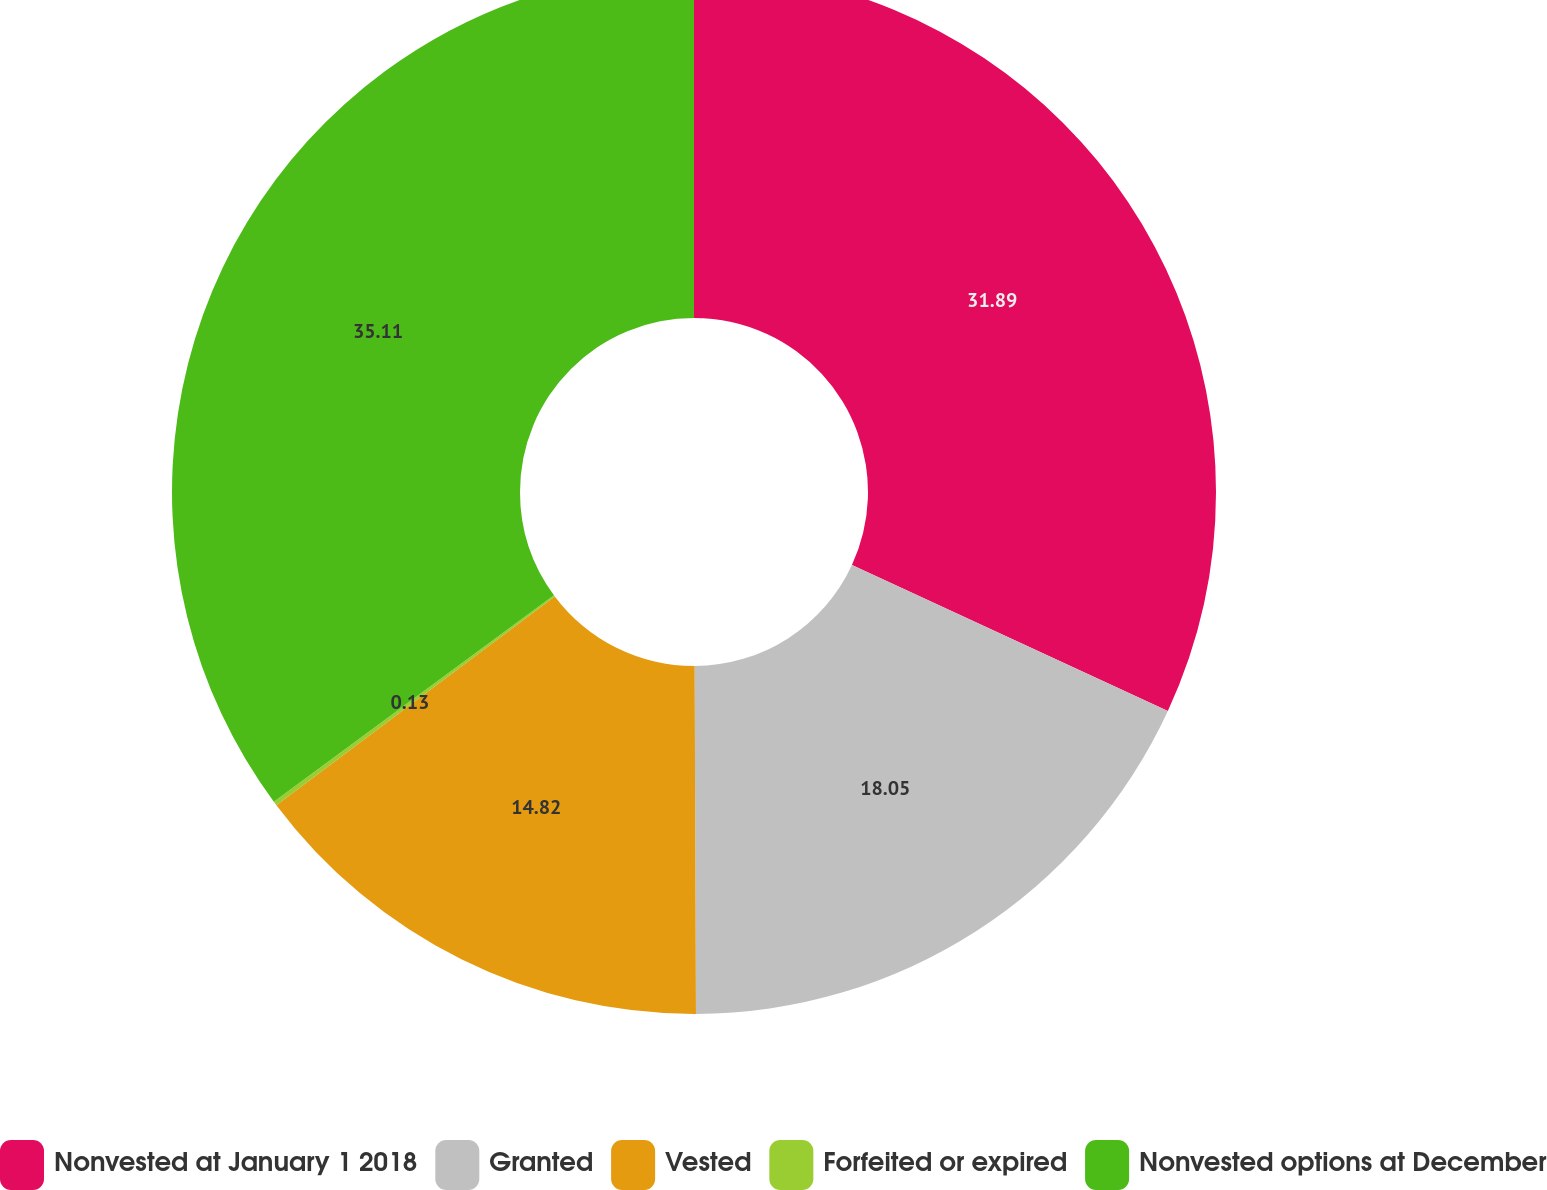Convert chart. <chart><loc_0><loc_0><loc_500><loc_500><pie_chart><fcel>Nonvested at January 1 2018<fcel>Granted<fcel>Vested<fcel>Forfeited or expired<fcel>Nonvested options at December<nl><fcel>31.89%<fcel>18.05%<fcel>14.82%<fcel>0.13%<fcel>35.11%<nl></chart> 